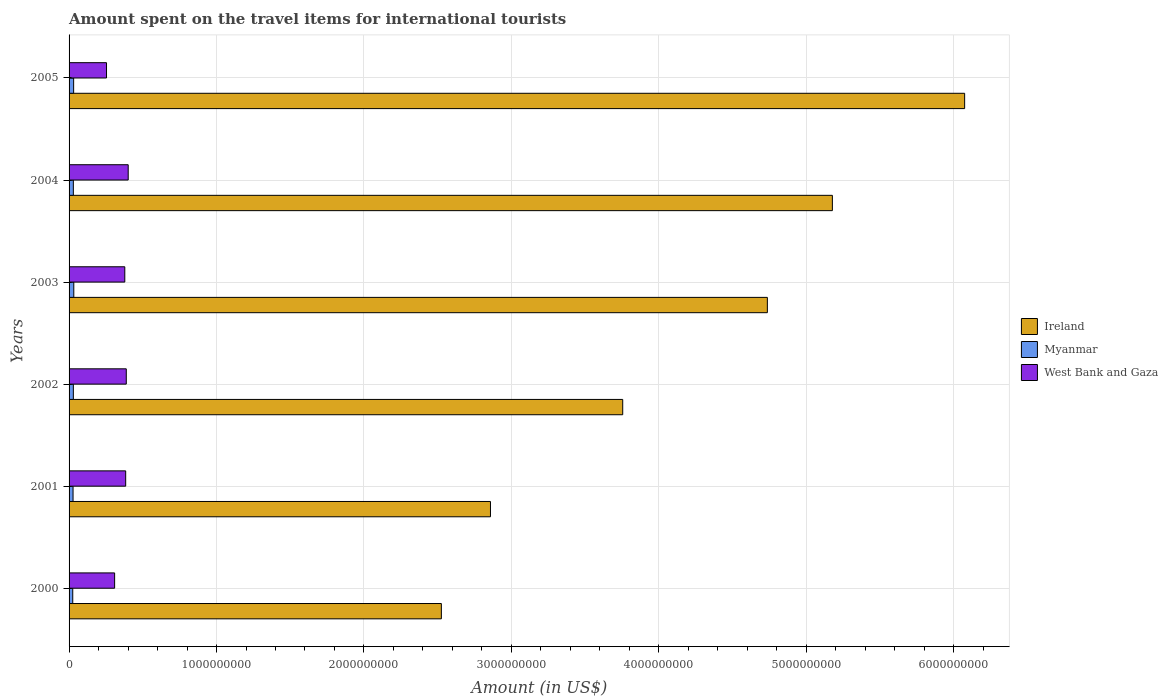How many groups of bars are there?
Make the answer very short. 6. Are the number of bars per tick equal to the number of legend labels?
Offer a terse response. Yes. How many bars are there on the 2nd tick from the bottom?
Provide a short and direct response. 3. In how many cases, is the number of bars for a given year not equal to the number of legend labels?
Offer a very short reply. 0. What is the amount spent on the travel items for international tourists in West Bank and Gaza in 2002?
Your answer should be compact. 3.88e+08. Across all years, what is the maximum amount spent on the travel items for international tourists in Myanmar?
Give a very brief answer. 3.20e+07. Across all years, what is the minimum amount spent on the travel items for international tourists in West Bank and Gaza?
Your answer should be very brief. 2.54e+08. In which year was the amount spent on the travel items for international tourists in Myanmar maximum?
Give a very brief answer. 2003. What is the total amount spent on the travel items for international tourists in West Bank and Gaza in the graph?
Your answer should be compact. 2.11e+09. What is the difference between the amount spent on the travel items for international tourists in Ireland in 2001 and that in 2005?
Offer a very short reply. -3.22e+09. What is the difference between the amount spent on the travel items for international tourists in Ireland in 2004 and the amount spent on the travel items for international tourists in West Bank and Gaza in 2002?
Provide a succinct answer. 4.79e+09. What is the average amount spent on the travel items for international tourists in Ireland per year?
Offer a terse response. 4.19e+09. In the year 2004, what is the difference between the amount spent on the travel items for international tourists in West Bank and Gaza and amount spent on the travel items for international tourists in Ireland?
Give a very brief answer. -4.78e+09. What is the ratio of the amount spent on the travel items for international tourists in Myanmar in 2002 to that in 2005?
Provide a short and direct response. 0.94. What is the difference between the highest and the second highest amount spent on the travel items for international tourists in Ireland?
Your answer should be very brief. 8.97e+08. What is the difference between the highest and the lowest amount spent on the travel items for international tourists in West Bank and Gaza?
Give a very brief answer. 1.47e+08. Is the sum of the amount spent on the travel items for international tourists in Myanmar in 2003 and 2005 greater than the maximum amount spent on the travel items for international tourists in Ireland across all years?
Offer a terse response. No. What does the 2nd bar from the top in 2000 represents?
Your response must be concise. Myanmar. What does the 1st bar from the bottom in 2000 represents?
Your answer should be compact. Ireland. Is it the case that in every year, the sum of the amount spent on the travel items for international tourists in West Bank and Gaza and amount spent on the travel items for international tourists in Ireland is greater than the amount spent on the travel items for international tourists in Myanmar?
Your response must be concise. Yes. Are all the bars in the graph horizontal?
Your answer should be very brief. Yes. How many years are there in the graph?
Ensure brevity in your answer.  6. What is the difference between two consecutive major ticks on the X-axis?
Offer a terse response. 1.00e+09. Where does the legend appear in the graph?
Provide a succinct answer. Center right. What is the title of the graph?
Offer a terse response. Amount spent on the travel items for international tourists. What is the label or title of the X-axis?
Offer a terse response. Amount (in US$). What is the Amount (in US$) of Ireland in 2000?
Provide a short and direct response. 2.52e+09. What is the Amount (in US$) in Myanmar in 2000?
Offer a very short reply. 2.50e+07. What is the Amount (in US$) of West Bank and Gaza in 2000?
Your answer should be very brief. 3.09e+08. What is the Amount (in US$) of Ireland in 2001?
Make the answer very short. 2.86e+09. What is the Amount (in US$) of Myanmar in 2001?
Your response must be concise. 2.70e+07. What is the Amount (in US$) in West Bank and Gaza in 2001?
Give a very brief answer. 3.84e+08. What is the Amount (in US$) of Ireland in 2002?
Ensure brevity in your answer.  3.76e+09. What is the Amount (in US$) of Myanmar in 2002?
Offer a terse response. 2.90e+07. What is the Amount (in US$) of West Bank and Gaza in 2002?
Provide a succinct answer. 3.88e+08. What is the Amount (in US$) of Ireland in 2003?
Your answer should be very brief. 4.74e+09. What is the Amount (in US$) of Myanmar in 2003?
Offer a terse response. 3.20e+07. What is the Amount (in US$) in West Bank and Gaza in 2003?
Keep it short and to the point. 3.78e+08. What is the Amount (in US$) of Ireland in 2004?
Provide a short and direct response. 5.18e+09. What is the Amount (in US$) of Myanmar in 2004?
Ensure brevity in your answer.  2.90e+07. What is the Amount (in US$) in West Bank and Gaza in 2004?
Your answer should be compact. 4.01e+08. What is the Amount (in US$) in Ireland in 2005?
Give a very brief answer. 6.07e+09. What is the Amount (in US$) in Myanmar in 2005?
Keep it short and to the point. 3.10e+07. What is the Amount (in US$) of West Bank and Gaza in 2005?
Provide a short and direct response. 2.54e+08. Across all years, what is the maximum Amount (in US$) of Ireland?
Offer a terse response. 6.07e+09. Across all years, what is the maximum Amount (in US$) in Myanmar?
Give a very brief answer. 3.20e+07. Across all years, what is the maximum Amount (in US$) of West Bank and Gaza?
Give a very brief answer. 4.01e+08. Across all years, what is the minimum Amount (in US$) of Ireland?
Your answer should be very brief. 2.52e+09. Across all years, what is the minimum Amount (in US$) in Myanmar?
Ensure brevity in your answer.  2.50e+07. Across all years, what is the minimum Amount (in US$) in West Bank and Gaza?
Offer a terse response. 2.54e+08. What is the total Amount (in US$) in Ireland in the graph?
Your answer should be very brief. 2.51e+1. What is the total Amount (in US$) of Myanmar in the graph?
Ensure brevity in your answer.  1.73e+08. What is the total Amount (in US$) of West Bank and Gaza in the graph?
Your answer should be compact. 2.11e+09. What is the difference between the Amount (in US$) of Ireland in 2000 and that in 2001?
Ensure brevity in your answer.  -3.33e+08. What is the difference between the Amount (in US$) in West Bank and Gaza in 2000 and that in 2001?
Offer a terse response. -7.50e+07. What is the difference between the Amount (in US$) in Ireland in 2000 and that in 2002?
Make the answer very short. -1.23e+09. What is the difference between the Amount (in US$) of Myanmar in 2000 and that in 2002?
Provide a succinct answer. -4.00e+06. What is the difference between the Amount (in US$) of West Bank and Gaza in 2000 and that in 2002?
Offer a terse response. -7.90e+07. What is the difference between the Amount (in US$) in Ireland in 2000 and that in 2003?
Offer a very short reply. -2.21e+09. What is the difference between the Amount (in US$) in Myanmar in 2000 and that in 2003?
Offer a very short reply. -7.00e+06. What is the difference between the Amount (in US$) in West Bank and Gaza in 2000 and that in 2003?
Provide a short and direct response. -6.90e+07. What is the difference between the Amount (in US$) of Ireland in 2000 and that in 2004?
Your answer should be compact. -2.65e+09. What is the difference between the Amount (in US$) of Myanmar in 2000 and that in 2004?
Offer a very short reply. -4.00e+06. What is the difference between the Amount (in US$) of West Bank and Gaza in 2000 and that in 2004?
Your response must be concise. -9.20e+07. What is the difference between the Amount (in US$) in Ireland in 2000 and that in 2005?
Make the answer very short. -3.55e+09. What is the difference between the Amount (in US$) in Myanmar in 2000 and that in 2005?
Give a very brief answer. -6.00e+06. What is the difference between the Amount (in US$) of West Bank and Gaza in 2000 and that in 2005?
Make the answer very short. 5.50e+07. What is the difference between the Amount (in US$) in Ireland in 2001 and that in 2002?
Offer a terse response. -8.97e+08. What is the difference between the Amount (in US$) of West Bank and Gaza in 2001 and that in 2002?
Keep it short and to the point. -4.00e+06. What is the difference between the Amount (in US$) in Ireland in 2001 and that in 2003?
Ensure brevity in your answer.  -1.88e+09. What is the difference between the Amount (in US$) of Myanmar in 2001 and that in 2003?
Your answer should be compact. -5.00e+06. What is the difference between the Amount (in US$) in Ireland in 2001 and that in 2004?
Your response must be concise. -2.32e+09. What is the difference between the Amount (in US$) of West Bank and Gaza in 2001 and that in 2004?
Your answer should be very brief. -1.70e+07. What is the difference between the Amount (in US$) in Ireland in 2001 and that in 2005?
Keep it short and to the point. -3.22e+09. What is the difference between the Amount (in US$) of West Bank and Gaza in 2001 and that in 2005?
Keep it short and to the point. 1.30e+08. What is the difference between the Amount (in US$) in Ireland in 2002 and that in 2003?
Give a very brief answer. -9.81e+08. What is the difference between the Amount (in US$) of Ireland in 2002 and that in 2004?
Ensure brevity in your answer.  -1.42e+09. What is the difference between the Amount (in US$) in Myanmar in 2002 and that in 2004?
Offer a very short reply. 0. What is the difference between the Amount (in US$) in West Bank and Gaza in 2002 and that in 2004?
Ensure brevity in your answer.  -1.30e+07. What is the difference between the Amount (in US$) in Ireland in 2002 and that in 2005?
Keep it short and to the point. -2.32e+09. What is the difference between the Amount (in US$) in Myanmar in 2002 and that in 2005?
Keep it short and to the point. -2.00e+06. What is the difference between the Amount (in US$) of West Bank and Gaza in 2002 and that in 2005?
Offer a terse response. 1.34e+08. What is the difference between the Amount (in US$) in Ireland in 2003 and that in 2004?
Provide a succinct answer. -4.41e+08. What is the difference between the Amount (in US$) in Myanmar in 2003 and that in 2004?
Make the answer very short. 3.00e+06. What is the difference between the Amount (in US$) in West Bank and Gaza in 2003 and that in 2004?
Offer a very short reply. -2.30e+07. What is the difference between the Amount (in US$) of Ireland in 2003 and that in 2005?
Keep it short and to the point. -1.34e+09. What is the difference between the Amount (in US$) of West Bank and Gaza in 2003 and that in 2005?
Your answer should be compact. 1.24e+08. What is the difference between the Amount (in US$) of Ireland in 2004 and that in 2005?
Your answer should be compact. -8.97e+08. What is the difference between the Amount (in US$) in West Bank and Gaza in 2004 and that in 2005?
Your response must be concise. 1.47e+08. What is the difference between the Amount (in US$) in Ireland in 2000 and the Amount (in US$) in Myanmar in 2001?
Keep it short and to the point. 2.50e+09. What is the difference between the Amount (in US$) in Ireland in 2000 and the Amount (in US$) in West Bank and Gaza in 2001?
Ensure brevity in your answer.  2.14e+09. What is the difference between the Amount (in US$) of Myanmar in 2000 and the Amount (in US$) of West Bank and Gaza in 2001?
Your answer should be very brief. -3.59e+08. What is the difference between the Amount (in US$) in Ireland in 2000 and the Amount (in US$) in Myanmar in 2002?
Your response must be concise. 2.50e+09. What is the difference between the Amount (in US$) in Ireland in 2000 and the Amount (in US$) in West Bank and Gaza in 2002?
Provide a succinct answer. 2.14e+09. What is the difference between the Amount (in US$) in Myanmar in 2000 and the Amount (in US$) in West Bank and Gaza in 2002?
Your response must be concise. -3.63e+08. What is the difference between the Amount (in US$) in Ireland in 2000 and the Amount (in US$) in Myanmar in 2003?
Give a very brief answer. 2.49e+09. What is the difference between the Amount (in US$) of Ireland in 2000 and the Amount (in US$) of West Bank and Gaza in 2003?
Keep it short and to the point. 2.15e+09. What is the difference between the Amount (in US$) in Myanmar in 2000 and the Amount (in US$) in West Bank and Gaza in 2003?
Your answer should be very brief. -3.53e+08. What is the difference between the Amount (in US$) of Ireland in 2000 and the Amount (in US$) of Myanmar in 2004?
Make the answer very short. 2.50e+09. What is the difference between the Amount (in US$) of Ireland in 2000 and the Amount (in US$) of West Bank and Gaza in 2004?
Your response must be concise. 2.12e+09. What is the difference between the Amount (in US$) of Myanmar in 2000 and the Amount (in US$) of West Bank and Gaza in 2004?
Your response must be concise. -3.76e+08. What is the difference between the Amount (in US$) of Ireland in 2000 and the Amount (in US$) of Myanmar in 2005?
Your response must be concise. 2.49e+09. What is the difference between the Amount (in US$) of Ireland in 2000 and the Amount (in US$) of West Bank and Gaza in 2005?
Your answer should be compact. 2.27e+09. What is the difference between the Amount (in US$) in Myanmar in 2000 and the Amount (in US$) in West Bank and Gaza in 2005?
Your answer should be very brief. -2.29e+08. What is the difference between the Amount (in US$) of Ireland in 2001 and the Amount (in US$) of Myanmar in 2002?
Give a very brief answer. 2.83e+09. What is the difference between the Amount (in US$) in Ireland in 2001 and the Amount (in US$) in West Bank and Gaza in 2002?
Your answer should be very brief. 2.47e+09. What is the difference between the Amount (in US$) of Myanmar in 2001 and the Amount (in US$) of West Bank and Gaza in 2002?
Offer a terse response. -3.61e+08. What is the difference between the Amount (in US$) of Ireland in 2001 and the Amount (in US$) of Myanmar in 2003?
Ensure brevity in your answer.  2.83e+09. What is the difference between the Amount (in US$) of Ireland in 2001 and the Amount (in US$) of West Bank and Gaza in 2003?
Offer a terse response. 2.48e+09. What is the difference between the Amount (in US$) in Myanmar in 2001 and the Amount (in US$) in West Bank and Gaza in 2003?
Give a very brief answer. -3.51e+08. What is the difference between the Amount (in US$) of Ireland in 2001 and the Amount (in US$) of Myanmar in 2004?
Offer a terse response. 2.83e+09. What is the difference between the Amount (in US$) in Ireland in 2001 and the Amount (in US$) in West Bank and Gaza in 2004?
Keep it short and to the point. 2.46e+09. What is the difference between the Amount (in US$) of Myanmar in 2001 and the Amount (in US$) of West Bank and Gaza in 2004?
Give a very brief answer. -3.74e+08. What is the difference between the Amount (in US$) in Ireland in 2001 and the Amount (in US$) in Myanmar in 2005?
Provide a succinct answer. 2.83e+09. What is the difference between the Amount (in US$) of Ireland in 2001 and the Amount (in US$) of West Bank and Gaza in 2005?
Provide a succinct answer. 2.60e+09. What is the difference between the Amount (in US$) in Myanmar in 2001 and the Amount (in US$) in West Bank and Gaza in 2005?
Keep it short and to the point. -2.27e+08. What is the difference between the Amount (in US$) of Ireland in 2002 and the Amount (in US$) of Myanmar in 2003?
Keep it short and to the point. 3.72e+09. What is the difference between the Amount (in US$) of Ireland in 2002 and the Amount (in US$) of West Bank and Gaza in 2003?
Give a very brief answer. 3.38e+09. What is the difference between the Amount (in US$) of Myanmar in 2002 and the Amount (in US$) of West Bank and Gaza in 2003?
Provide a short and direct response. -3.49e+08. What is the difference between the Amount (in US$) of Ireland in 2002 and the Amount (in US$) of Myanmar in 2004?
Provide a succinct answer. 3.73e+09. What is the difference between the Amount (in US$) in Ireland in 2002 and the Amount (in US$) in West Bank and Gaza in 2004?
Your response must be concise. 3.35e+09. What is the difference between the Amount (in US$) in Myanmar in 2002 and the Amount (in US$) in West Bank and Gaza in 2004?
Your answer should be very brief. -3.72e+08. What is the difference between the Amount (in US$) in Ireland in 2002 and the Amount (in US$) in Myanmar in 2005?
Your answer should be very brief. 3.72e+09. What is the difference between the Amount (in US$) in Ireland in 2002 and the Amount (in US$) in West Bank and Gaza in 2005?
Provide a short and direct response. 3.50e+09. What is the difference between the Amount (in US$) of Myanmar in 2002 and the Amount (in US$) of West Bank and Gaza in 2005?
Your response must be concise. -2.25e+08. What is the difference between the Amount (in US$) in Ireland in 2003 and the Amount (in US$) in Myanmar in 2004?
Your answer should be compact. 4.71e+09. What is the difference between the Amount (in US$) in Ireland in 2003 and the Amount (in US$) in West Bank and Gaza in 2004?
Keep it short and to the point. 4.34e+09. What is the difference between the Amount (in US$) of Myanmar in 2003 and the Amount (in US$) of West Bank and Gaza in 2004?
Make the answer very short. -3.69e+08. What is the difference between the Amount (in US$) of Ireland in 2003 and the Amount (in US$) of Myanmar in 2005?
Your response must be concise. 4.70e+09. What is the difference between the Amount (in US$) in Ireland in 2003 and the Amount (in US$) in West Bank and Gaza in 2005?
Your answer should be very brief. 4.48e+09. What is the difference between the Amount (in US$) in Myanmar in 2003 and the Amount (in US$) in West Bank and Gaza in 2005?
Keep it short and to the point. -2.22e+08. What is the difference between the Amount (in US$) of Ireland in 2004 and the Amount (in US$) of Myanmar in 2005?
Your answer should be compact. 5.15e+09. What is the difference between the Amount (in US$) of Ireland in 2004 and the Amount (in US$) of West Bank and Gaza in 2005?
Give a very brief answer. 4.92e+09. What is the difference between the Amount (in US$) in Myanmar in 2004 and the Amount (in US$) in West Bank and Gaza in 2005?
Offer a very short reply. -2.25e+08. What is the average Amount (in US$) in Ireland per year?
Give a very brief answer. 4.19e+09. What is the average Amount (in US$) of Myanmar per year?
Keep it short and to the point. 2.88e+07. What is the average Amount (in US$) in West Bank and Gaza per year?
Make the answer very short. 3.52e+08. In the year 2000, what is the difference between the Amount (in US$) of Ireland and Amount (in US$) of Myanmar?
Keep it short and to the point. 2.50e+09. In the year 2000, what is the difference between the Amount (in US$) in Ireland and Amount (in US$) in West Bank and Gaza?
Keep it short and to the point. 2.22e+09. In the year 2000, what is the difference between the Amount (in US$) in Myanmar and Amount (in US$) in West Bank and Gaza?
Make the answer very short. -2.84e+08. In the year 2001, what is the difference between the Amount (in US$) in Ireland and Amount (in US$) in Myanmar?
Ensure brevity in your answer.  2.83e+09. In the year 2001, what is the difference between the Amount (in US$) of Ireland and Amount (in US$) of West Bank and Gaza?
Your answer should be compact. 2.47e+09. In the year 2001, what is the difference between the Amount (in US$) in Myanmar and Amount (in US$) in West Bank and Gaza?
Provide a succinct answer. -3.57e+08. In the year 2002, what is the difference between the Amount (in US$) in Ireland and Amount (in US$) in Myanmar?
Provide a short and direct response. 3.73e+09. In the year 2002, what is the difference between the Amount (in US$) of Ireland and Amount (in US$) of West Bank and Gaza?
Offer a very short reply. 3.37e+09. In the year 2002, what is the difference between the Amount (in US$) in Myanmar and Amount (in US$) in West Bank and Gaza?
Offer a terse response. -3.59e+08. In the year 2003, what is the difference between the Amount (in US$) in Ireland and Amount (in US$) in Myanmar?
Keep it short and to the point. 4.70e+09. In the year 2003, what is the difference between the Amount (in US$) in Ireland and Amount (in US$) in West Bank and Gaza?
Your answer should be compact. 4.36e+09. In the year 2003, what is the difference between the Amount (in US$) in Myanmar and Amount (in US$) in West Bank and Gaza?
Offer a terse response. -3.46e+08. In the year 2004, what is the difference between the Amount (in US$) of Ireland and Amount (in US$) of Myanmar?
Your answer should be very brief. 5.15e+09. In the year 2004, what is the difference between the Amount (in US$) in Ireland and Amount (in US$) in West Bank and Gaza?
Your response must be concise. 4.78e+09. In the year 2004, what is the difference between the Amount (in US$) of Myanmar and Amount (in US$) of West Bank and Gaza?
Make the answer very short. -3.72e+08. In the year 2005, what is the difference between the Amount (in US$) of Ireland and Amount (in US$) of Myanmar?
Keep it short and to the point. 6.04e+09. In the year 2005, what is the difference between the Amount (in US$) in Ireland and Amount (in US$) in West Bank and Gaza?
Make the answer very short. 5.82e+09. In the year 2005, what is the difference between the Amount (in US$) of Myanmar and Amount (in US$) of West Bank and Gaza?
Offer a very short reply. -2.23e+08. What is the ratio of the Amount (in US$) in Ireland in 2000 to that in 2001?
Offer a terse response. 0.88. What is the ratio of the Amount (in US$) of Myanmar in 2000 to that in 2001?
Your response must be concise. 0.93. What is the ratio of the Amount (in US$) in West Bank and Gaza in 2000 to that in 2001?
Provide a succinct answer. 0.8. What is the ratio of the Amount (in US$) of Ireland in 2000 to that in 2002?
Offer a very short reply. 0.67. What is the ratio of the Amount (in US$) of Myanmar in 2000 to that in 2002?
Keep it short and to the point. 0.86. What is the ratio of the Amount (in US$) in West Bank and Gaza in 2000 to that in 2002?
Your response must be concise. 0.8. What is the ratio of the Amount (in US$) in Ireland in 2000 to that in 2003?
Give a very brief answer. 0.53. What is the ratio of the Amount (in US$) in Myanmar in 2000 to that in 2003?
Keep it short and to the point. 0.78. What is the ratio of the Amount (in US$) of West Bank and Gaza in 2000 to that in 2003?
Keep it short and to the point. 0.82. What is the ratio of the Amount (in US$) of Ireland in 2000 to that in 2004?
Provide a succinct answer. 0.49. What is the ratio of the Amount (in US$) in Myanmar in 2000 to that in 2004?
Provide a short and direct response. 0.86. What is the ratio of the Amount (in US$) of West Bank and Gaza in 2000 to that in 2004?
Your answer should be very brief. 0.77. What is the ratio of the Amount (in US$) of Ireland in 2000 to that in 2005?
Provide a short and direct response. 0.42. What is the ratio of the Amount (in US$) of Myanmar in 2000 to that in 2005?
Your response must be concise. 0.81. What is the ratio of the Amount (in US$) in West Bank and Gaza in 2000 to that in 2005?
Provide a succinct answer. 1.22. What is the ratio of the Amount (in US$) of Ireland in 2001 to that in 2002?
Keep it short and to the point. 0.76. What is the ratio of the Amount (in US$) of Ireland in 2001 to that in 2003?
Ensure brevity in your answer.  0.6. What is the ratio of the Amount (in US$) of Myanmar in 2001 to that in 2003?
Ensure brevity in your answer.  0.84. What is the ratio of the Amount (in US$) of West Bank and Gaza in 2001 to that in 2003?
Offer a terse response. 1.02. What is the ratio of the Amount (in US$) of Ireland in 2001 to that in 2004?
Ensure brevity in your answer.  0.55. What is the ratio of the Amount (in US$) of Myanmar in 2001 to that in 2004?
Provide a short and direct response. 0.93. What is the ratio of the Amount (in US$) of West Bank and Gaza in 2001 to that in 2004?
Provide a succinct answer. 0.96. What is the ratio of the Amount (in US$) in Ireland in 2001 to that in 2005?
Give a very brief answer. 0.47. What is the ratio of the Amount (in US$) of Myanmar in 2001 to that in 2005?
Offer a very short reply. 0.87. What is the ratio of the Amount (in US$) of West Bank and Gaza in 2001 to that in 2005?
Your answer should be compact. 1.51. What is the ratio of the Amount (in US$) in Ireland in 2002 to that in 2003?
Make the answer very short. 0.79. What is the ratio of the Amount (in US$) of Myanmar in 2002 to that in 2003?
Your answer should be very brief. 0.91. What is the ratio of the Amount (in US$) of West Bank and Gaza in 2002 to that in 2003?
Offer a very short reply. 1.03. What is the ratio of the Amount (in US$) of Ireland in 2002 to that in 2004?
Offer a very short reply. 0.73. What is the ratio of the Amount (in US$) in West Bank and Gaza in 2002 to that in 2004?
Offer a very short reply. 0.97. What is the ratio of the Amount (in US$) of Ireland in 2002 to that in 2005?
Your answer should be compact. 0.62. What is the ratio of the Amount (in US$) of Myanmar in 2002 to that in 2005?
Your response must be concise. 0.94. What is the ratio of the Amount (in US$) of West Bank and Gaza in 2002 to that in 2005?
Give a very brief answer. 1.53. What is the ratio of the Amount (in US$) in Ireland in 2003 to that in 2004?
Make the answer very short. 0.91. What is the ratio of the Amount (in US$) of Myanmar in 2003 to that in 2004?
Give a very brief answer. 1.1. What is the ratio of the Amount (in US$) in West Bank and Gaza in 2003 to that in 2004?
Your answer should be compact. 0.94. What is the ratio of the Amount (in US$) of Ireland in 2003 to that in 2005?
Your answer should be very brief. 0.78. What is the ratio of the Amount (in US$) of Myanmar in 2003 to that in 2005?
Your answer should be very brief. 1.03. What is the ratio of the Amount (in US$) in West Bank and Gaza in 2003 to that in 2005?
Offer a very short reply. 1.49. What is the ratio of the Amount (in US$) in Ireland in 2004 to that in 2005?
Provide a succinct answer. 0.85. What is the ratio of the Amount (in US$) of Myanmar in 2004 to that in 2005?
Make the answer very short. 0.94. What is the ratio of the Amount (in US$) of West Bank and Gaza in 2004 to that in 2005?
Offer a very short reply. 1.58. What is the difference between the highest and the second highest Amount (in US$) of Ireland?
Provide a short and direct response. 8.97e+08. What is the difference between the highest and the second highest Amount (in US$) of Myanmar?
Your response must be concise. 1.00e+06. What is the difference between the highest and the second highest Amount (in US$) of West Bank and Gaza?
Offer a very short reply. 1.30e+07. What is the difference between the highest and the lowest Amount (in US$) in Ireland?
Offer a terse response. 3.55e+09. What is the difference between the highest and the lowest Amount (in US$) of Myanmar?
Offer a terse response. 7.00e+06. What is the difference between the highest and the lowest Amount (in US$) of West Bank and Gaza?
Give a very brief answer. 1.47e+08. 